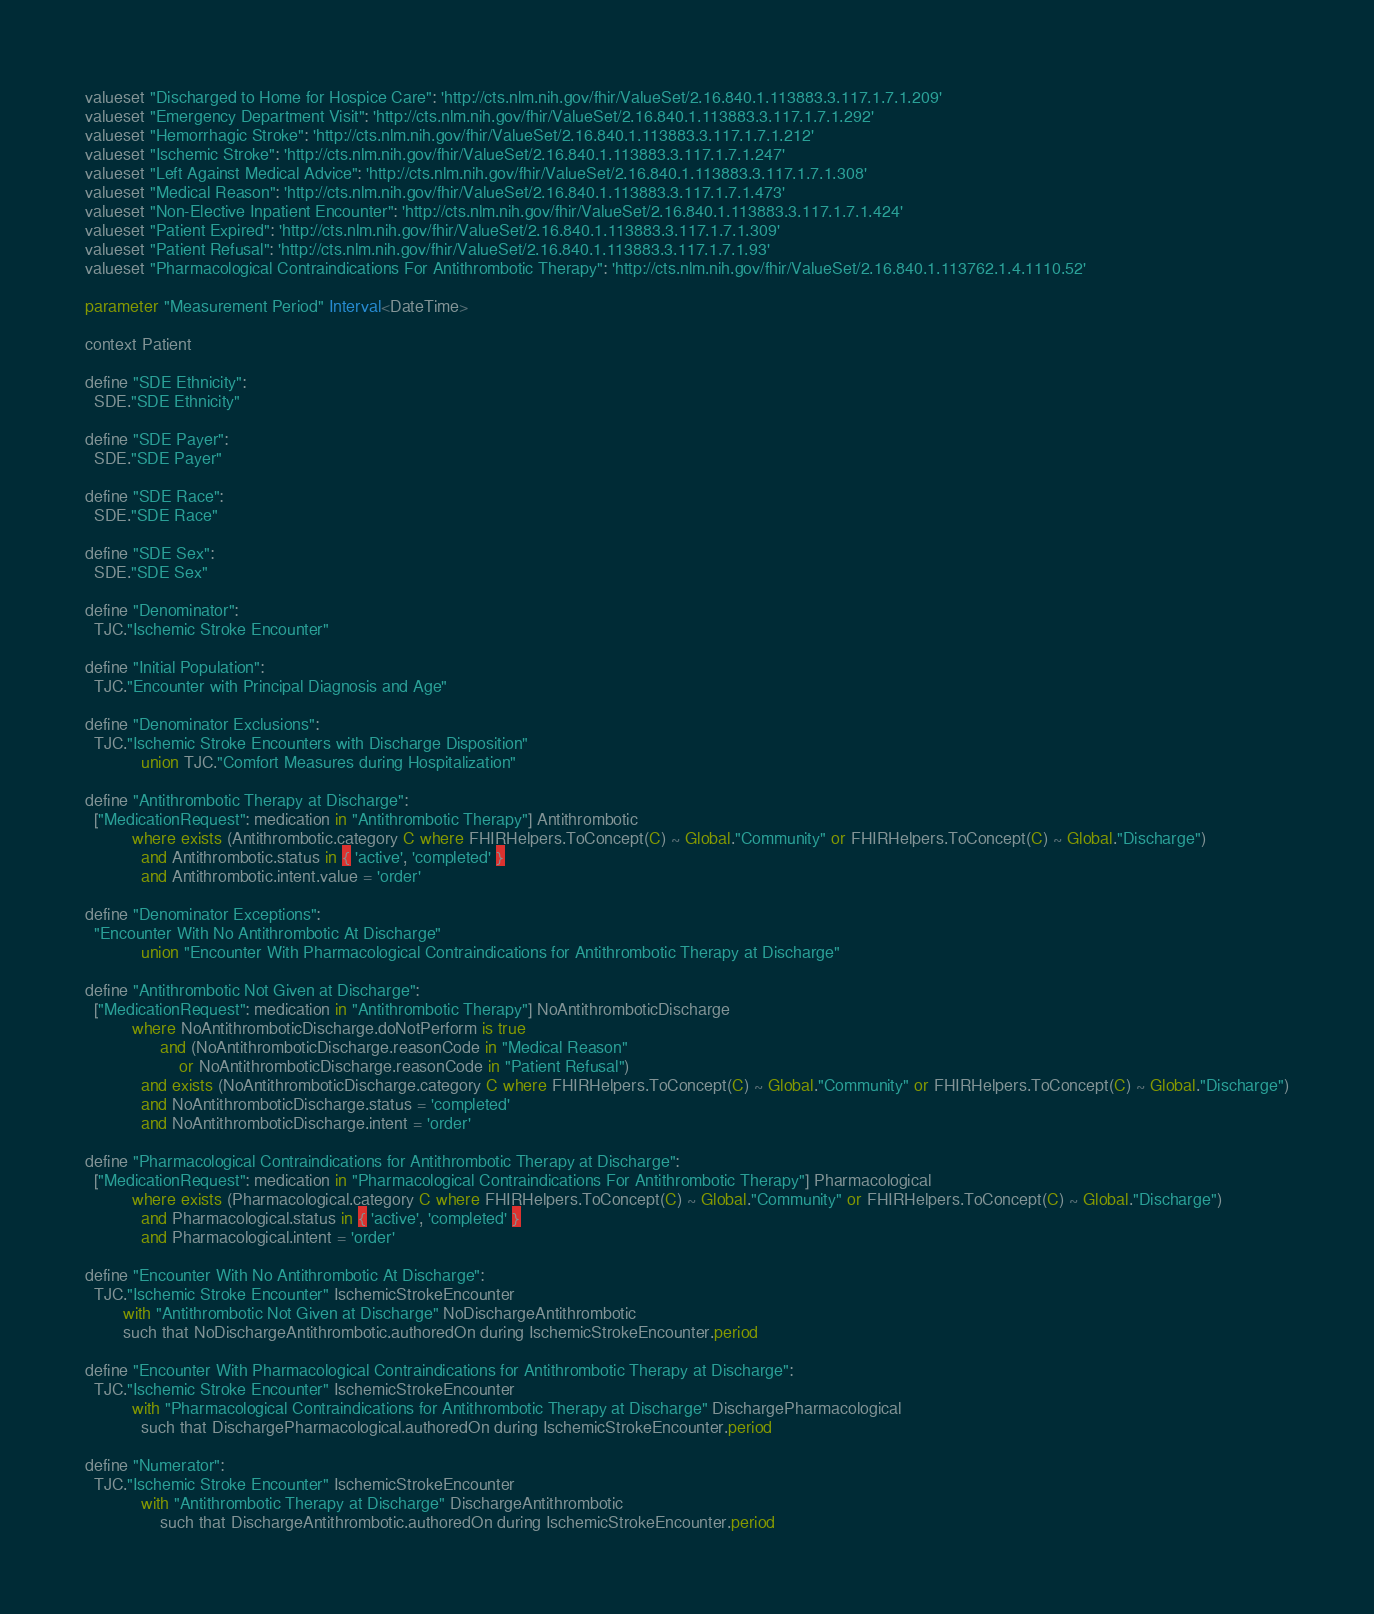<code> <loc_0><loc_0><loc_500><loc_500><_SQL_>valueset "Discharged to Home for Hospice Care": 'http://cts.nlm.nih.gov/fhir/ValueSet/2.16.840.1.113883.3.117.1.7.1.209' 
valueset "Emergency Department Visit": 'http://cts.nlm.nih.gov/fhir/ValueSet/2.16.840.1.113883.3.117.1.7.1.292' 
valueset "Hemorrhagic Stroke": 'http://cts.nlm.nih.gov/fhir/ValueSet/2.16.840.1.113883.3.117.1.7.1.212' 
valueset "Ischemic Stroke": 'http://cts.nlm.nih.gov/fhir/ValueSet/2.16.840.1.113883.3.117.1.7.1.247' 
valueset "Left Against Medical Advice": 'http://cts.nlm.nih.gov/fhir/ValueSet/2.16.840.1.113883.3.117.1.7.1.308' 
valueset "Medical Reason": 'http://cts.nlm.nih.gov/fhir/ValueSet/2.16.840.1.113883.3.117.1.7.1.473' 
valueset "Non-Elective Inpatient Encounter": 'http://cts.nlm.nih.gov/fhir/ValueSet/2.16.840.1.113883.3.117.1.7.1.424' 
valueset "Patient Expired": 'http://cts.nlm.nih.gov/fhir/ValueSet/2.16.840.1.113883.3.117.1.7.1.309' 
valueset "Patient Refusal": 'http://cts.nlm.nih.gov/fhir/ValueSet/2.16.840.1.113883.3.117.1.7.1.93' 
valueset "Pharmacological Contraindications For Antithrombotic Therapy": 'http://cts.nlm.nih.gov/fhir/ValueSet/2.16.840.1.113762.1.4.1110.52' 

parameter "Measurement Period" Interval<DateTime>

context Patient

define "SDE Ethnicity":
  SDE."SDE Ethnicity"

define "SDE Payer":
  SDE."SDE Payer"

define "SDE Race":
  SDE."SDE Race"

define "SDE Sex":
  SDE."SDE Sex"

define "Denominator":
  TJC."Ischemic Stroke Encounter"

define "Initial Population":
  TJC."Encounter with Principal Diagnosis and Age"

define "Denominator Exclusions":
  TJC."Ischemic Stroke Encounters with Discharge Disposition"
      		union TJC."Comfort Measures during Hospitalization"

define "Antithrombotic Therapy at Discharge":
  ["MedicationRequest": medication in "Antithrombotic Therapy"] Antithrombotic
      	  where exists (Antithrombotic.category C where FHIRHelpers.ToConcept(C) ~ Global."Community" or FHIRHelpers.ToConcept(C) ~ Global."Discharge")
            and Antithrombotic.status in { 'active', 'completed' }
      	    and Antithrombotic.intent.value = 'order'

define "Denominator Exceptions":
  "Encounter With No Antithrombotic At Discharge"
      		union "Encounter With Pharmacological Contraindications for Antithrombotic Therapy at Discharge"

define "Antithrombotic Not Given at Discharge":
  ["MedicationRequest": medication in "Antithrombotic Therapy"] NoAntithromboticDischarge
          where NoAntithromboticDischarge.doNotPerform is true
      			and (NoAntithromboticDischarge.reasonCode in "Medical Reason"
      				or NoAntithromboticDischarge.reasonCode in "Patient Refusal")
            and exists (NoAntithromboticDischarge.category C where FHIRHelpers.ToConcept(C) ~ Global."Community" or FHIRHelpers.ToConcept(C) ~ Global."Discharge")
            and NoAntithromboticDischarge.status = 'completed'
            and NoAntithromboticDischarge.intent = 'order'

define "Pharmacological Contraindications for Antithrombotic Therapy at Discharge":
  ["MedicationRequest": medication in "Pharmacological Contraindications For Antithrombotic Therapy"] Pharmacological
          where exists (Pharmacological.category C where FHIRHelpers.ToConcept(C) ~ Global."Community" or FHIRHelpers.ToConcept(C) ~ Global."Discharge")
            and Pharmacological.status in { 'active', 'completed' }
            and Pharmacological.intent = 'order'

define "Encounter With No Antithrombotic At Discharge":
  TJC."Ischemic Stroke Encounter" IschemicStrokeEncounter
      	with "Antithrombotic Not Given at Discharge" NoDischargeAntithrombotic
      	such that NoDischargeAntithrombotic.authoredOn during IschemicStrokeEncounter.period

define "Encounter With Pharmacological Contraindications for Antithrombotic Therapy at Discharge":
  TJC."Ischemic Stroke Encounter" IschemicStrokeEncounter
          with "Pharmacological Contraindications for Antithrombotic Therapy at Discharge" DischargePharmacological
            such that DischargePharmacological.authoredOn during IschemicStrokeEncounter.period

define "Numerator":
  TJC."Ischemic Stroke Encounter" IschemicStrokeEncounter
      		with "Antithrombotic Therapy at Discharge" DischargeAntithrombotic
      			such that DischargeAntithrombotic.authoredOn during IschemicStrokeEncounter.period

</code> 